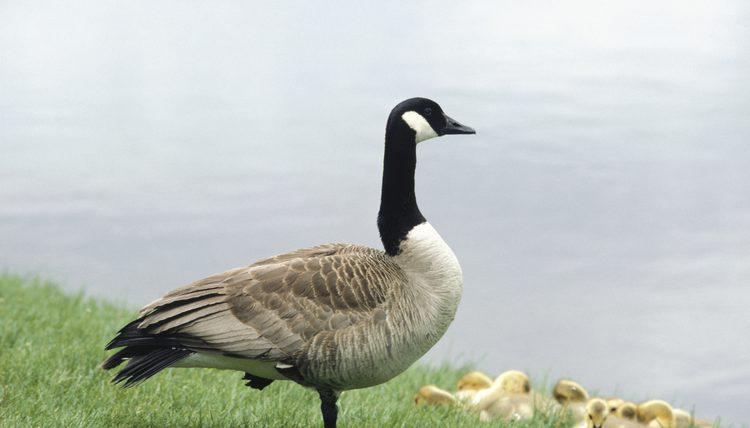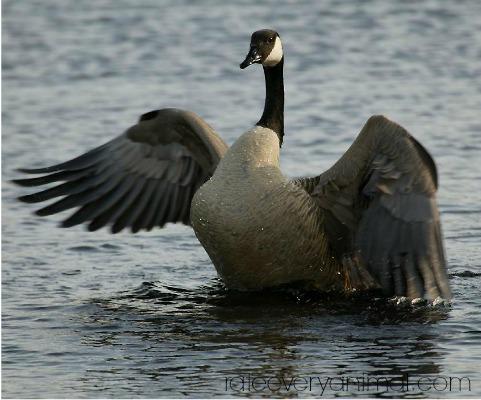The first image is the image on the left, the second image is the image on the right. For the images displayed, is the sentence "In one of the images, a goose is flapping its wings while on the water" factually correct? Answer yes or no. Yes. 